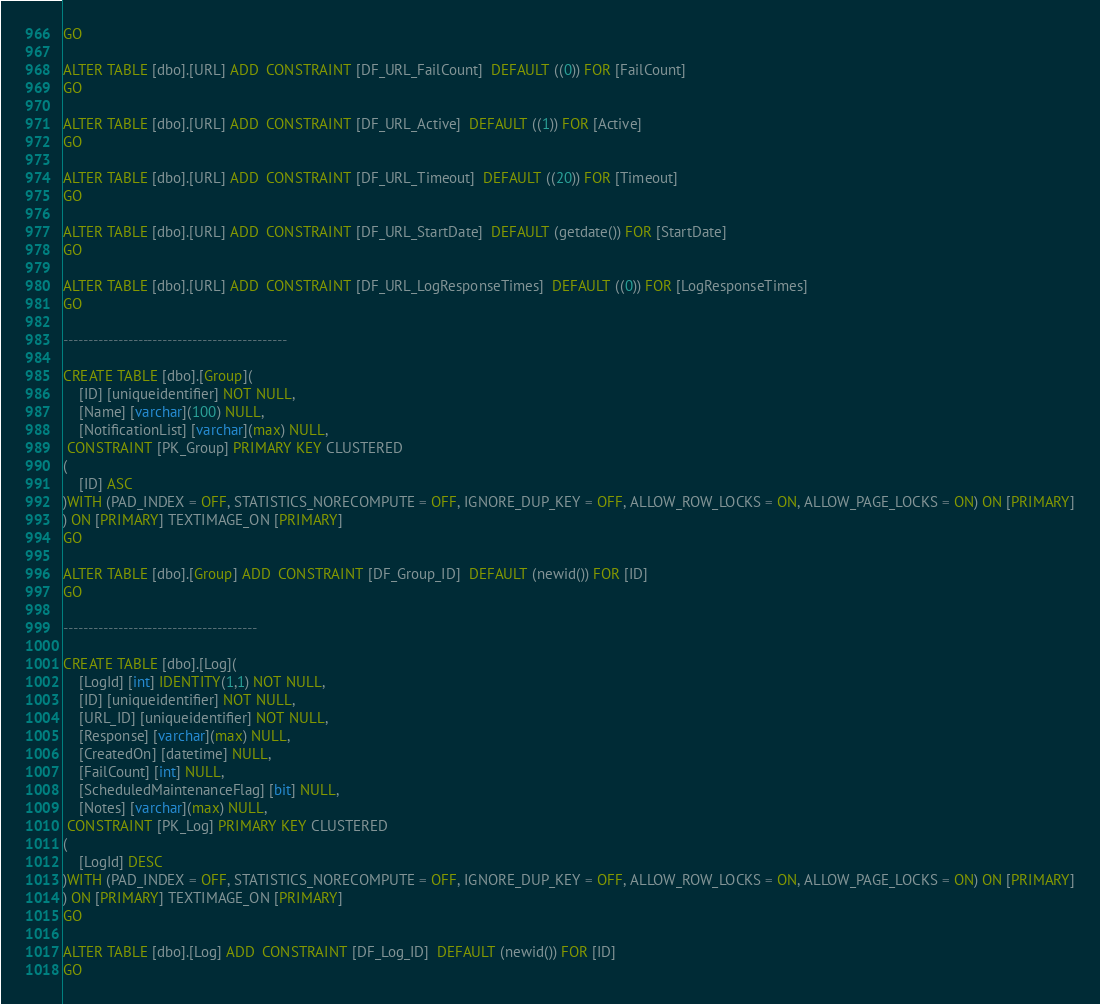Convert code to text. <code><loc_0><loc_0><loc_500><loc_500><_SQL_>GO

ALTER TABLE [dbo].[URL] ADD  CONSTRAINT [DF_URL_FailCount]  DEFAULT ((0)) FOR [FailCount]
GO

ALTER TABLE [dbo].[URL] ADD  CONSTRAINT [DF_URL_Active]  DEFAULT ((1)) FOR [Active]
GO

ALTER TABLE [dbo].[URL] ADD  CONSTRAINT [DF_URL_Timeout]  DEFAULT ((20)) FOR [Timeout]
GO

ALTER TABLE [dbo].[URL] ADD  CONSTRAINT [DF_URL_StartDate]  DEFAULT (getdate()) FOR [StartDate]
GO

ALTER TABLE [dbo].[URL] ADD  CONSTRAINT [DF_URL_LogResponseTimes]  DEFAULT ((0)) FOR [LogResponseTimes]
GO

---------------------------------------------

CREATE TABLE [dbo].[Group](
	[ID] [uniqueidentifier] NOT NULL,
	[Name] [varchar](100) NULL,
	[NotificationList] [varchar](max) NULL,
 CONSTRAINT [PK_Group] PRIMARY KEY CLUSTERED 
(
	[ID] ASC
)WITH (PAD_INDEX = OFF, STATISTICS_NORECOMPUTE = OFF, IGNORE_DUP_KEY = OFF, ALLOW_ROW_LOCKS = ON, ALLOW_PAGE_LOCKS = ON) ON [PRIMARY]
) ON [PRIMARY] TEXTIMAGE_ON [PRIMARY]
GO

ALTER TABLE [dbo].[Group] ADD  CONSTRAINT [DF_Group_ID]  DEFAULT (newid()) FOR [ID]
GO

---------------------------------------

CREATE TABLE [dbo].[Log](
	[LogId] [int] IDENTITY(1,1) NOT NULL,
	[ID] [uniqueidentifier] NOT NULL,
	[URL_ID] [uniqueidentifier] NOT NULL,
	[Response] [varchar](max) NULL,
	[CreatedOn] [datetime] NULL,
	[FailCount] [int] NULL,
	[ScheduledMaintenanceFlag] [bit] NULL,
	[Notes] [varchar](max) NULL,
 CONSTRAINT [PK_Log] PRIMARY KEY CLUSTERED 
(
	[LogId] DESC
)WITH (PAD_INDEX = OFF, STATISTICS_NORECOMPUTE = OFF, IGNORE_DUP_KEY = OFF, ALLOW_ROW_LOCKS = ON, ALLOW_PAGE_LOCKS = ON) ON [PRIMARY]
) ON [PRIMARY] TEXTIMAGE_ON [PRIMARY]
GO

ALTER TABLE [dbo].[Log] ADD  CONSTRAINT [DF_Log_ID]  DEFAULT (newid()) FOR [ID]
GO
</code> 